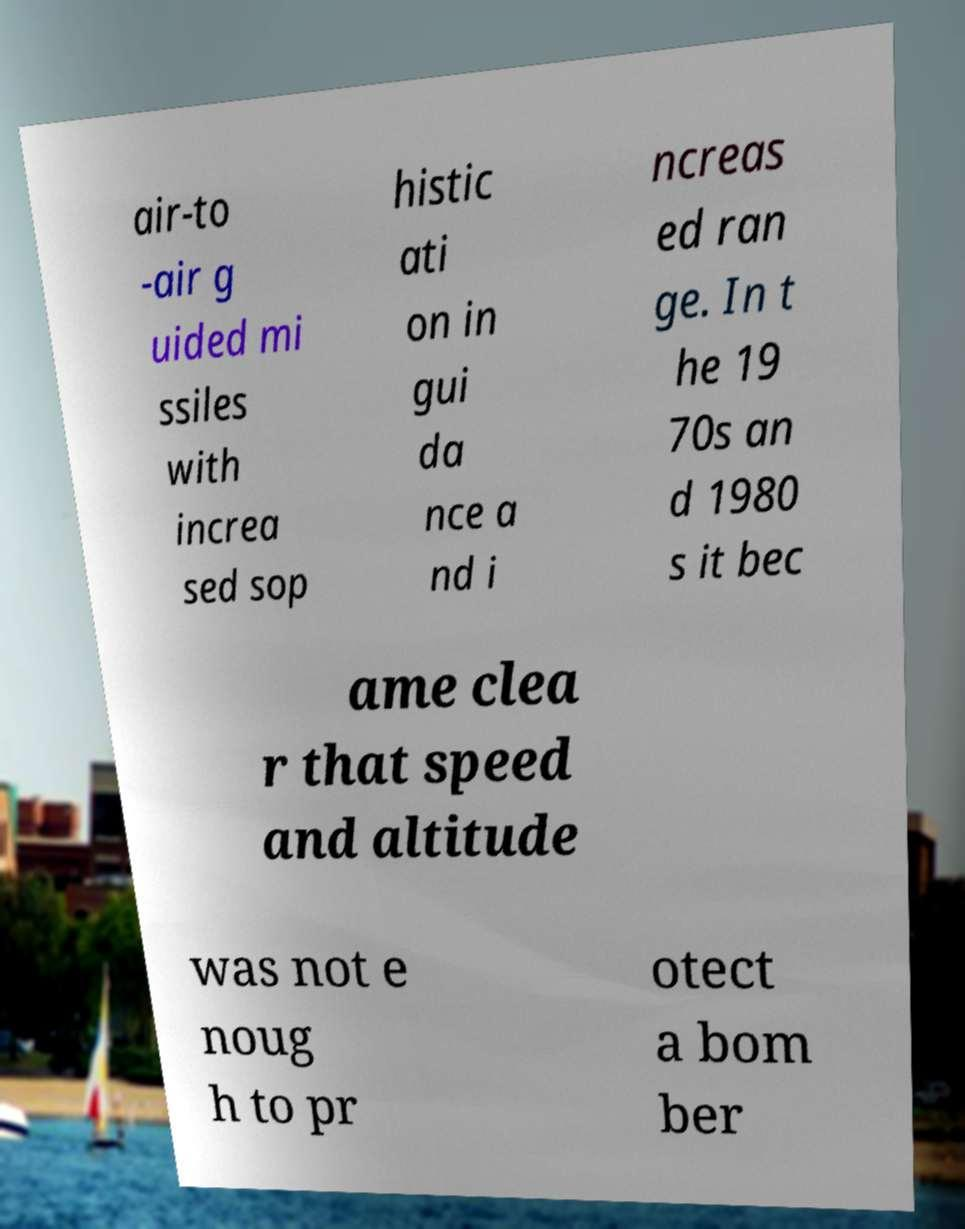Can you accurately transcribe the text from the provided image for me? air-to -air g uided mi ssiles with increa sed sop histic ati on in gui da nce a nd i ncreas ed ran ge. In t he 19 70s an d 1980 s it bec ame clea r that speed and altitude was not e noug h to pr otect a bom ber 